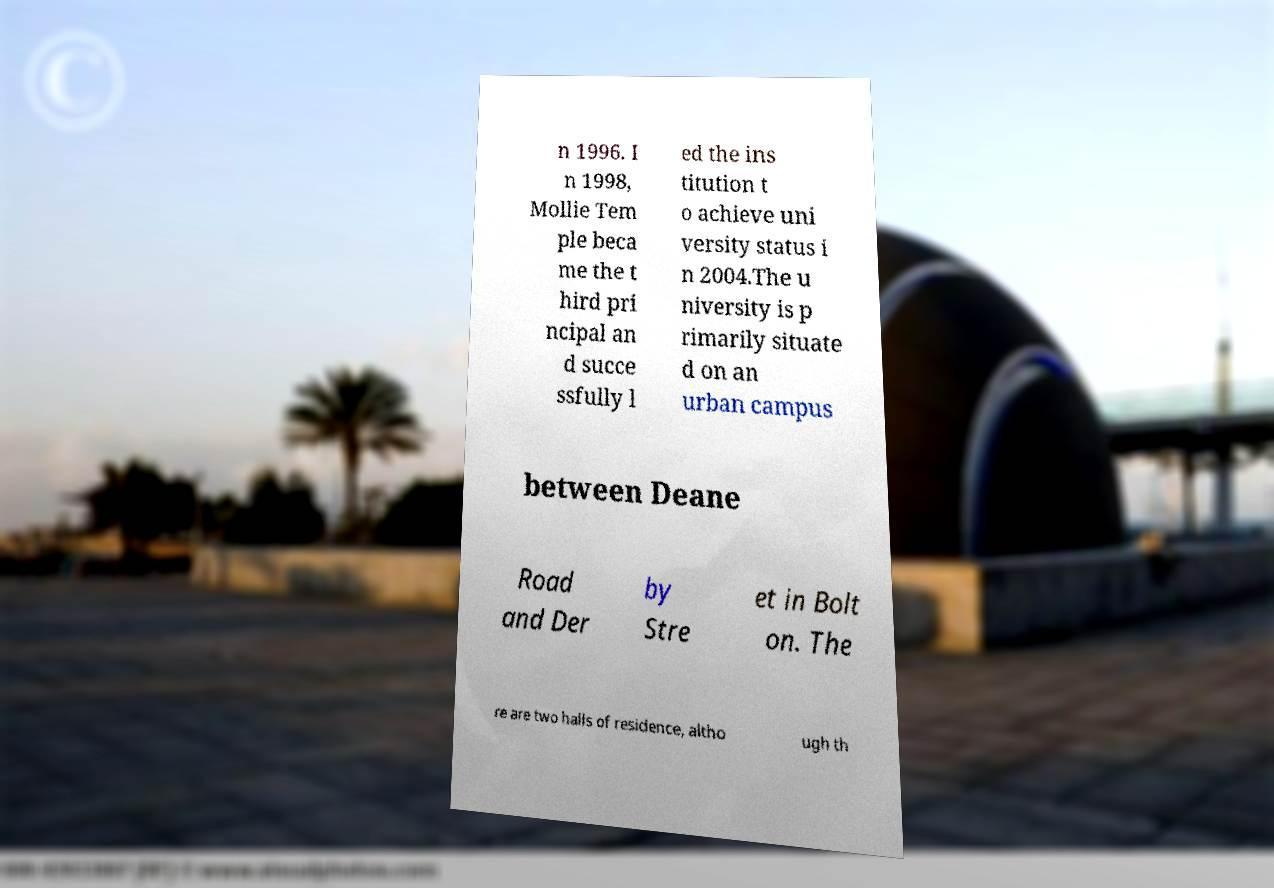Can you read and provide the text displayed in the image?This photo seems to have some interesting text. Can you extract and type it out for me? n 1996. I n 1998, Mollie Tem ple beca me the t hird pri ncipal an d succe ssfully l ed the ins titution t o achieve uni versity status i n 2004.The u niversity is p rimarily situate d on an urban campus between Deane Road and Der by Stre et in Bolt on. The re are two halls of residence, altho ugh th 